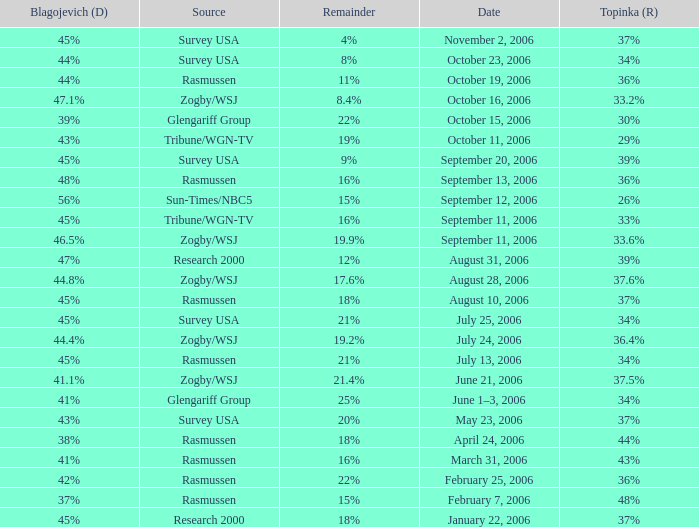Which Date has a Remainder of 20%? May 23, 2006. 